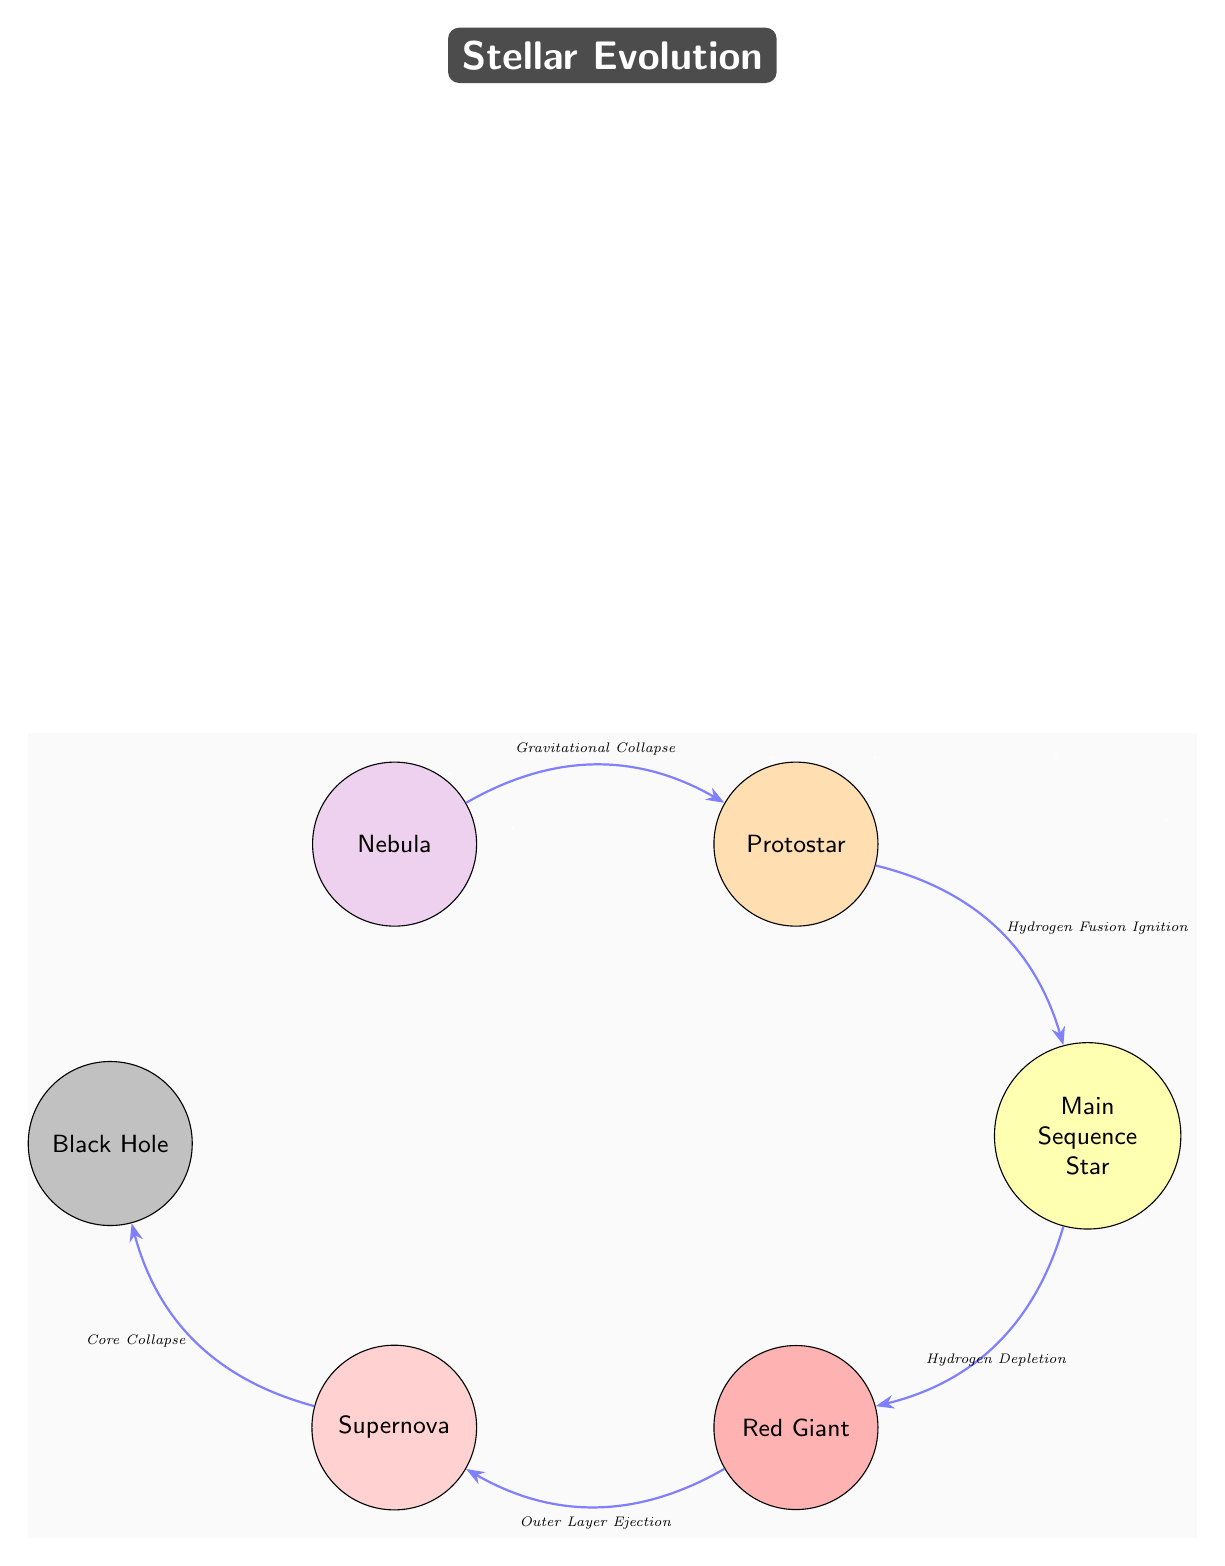What is the first stage of star formation shown in the diagram? The diagram clearly labels the first stage as "Nebula", which is the starting point of star formation.
Answer: Nebula How many stages are displayed in the stellar evolution sequence? By counting the nodes in the diagram, we see there are six distinct stages: Nebula, Protostar, Main Sequence Star, Red Giant, Supernova, and Black Hole.
Answer: Six What process leads from the protostar to the main sequence star? The arrow connecting the protostar to the main sequence star is labeled "Hydrogen Fusion Ignition", indicating this is the process that occurs during this transition.
Answer: Hydrogen Fusion Ignition Which star stage is connected to the black hole? The diagram shows that the black hole is reached through the "Core Collapse" of a supernova, as indicated by the arrow connecting these two nodes.
Answer: Supernova What color represents the red giant in the diagram? The red giant is represented in the diagram by the color red, which is visually denoted by the fill color of the corresponding node.
Answer: Red What occurs after hydrogen depletion in the lifecycle of a star? According to the diagram, after hydrogen depletion occurs in the main sequence, it transitions into the red giant stage, as illustrated by the connecting edge.
Answer: Red Giant Which node comes before the black hole in the diagram? The black hole follows the supernova stage in the sequence, so the supernova node is directly connected before reaching the black hole node.
Answer: Supernova What type of edge connects all the stages in the diagram? The edges connecting each of the stages of stellar evolution are described as "Stealth" arrows, which is a specific style chosen for indicating the processes between stages.
Answer: Stealth What background effect is visible throughout the diagram? The diagram features a starry background effect, with randomly placed white dots that represent stars, adding a celestial ambiance to the visual.
Answer: Starry background 